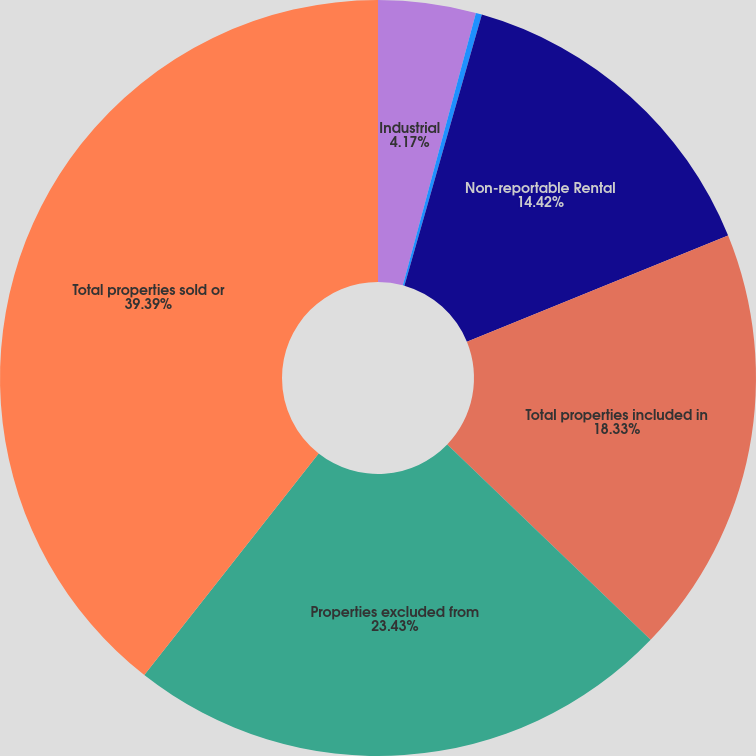Convert chart to OTSL. <chart><loc_0><loc_0><loc_500><loc_500><pie_chart><fcel>Industrial<fcel>Medical Office<fcel>Non-reportable Rental<fcel>Total properties included in<fcel>Properties excluded from<fcel>Total properties sold or<nl><fcel>4.17%<fcel>0.26%<fcel>14.42%<fcel>18.33%<fcel>23.43%<fcel>39.39%<nl></chart> 